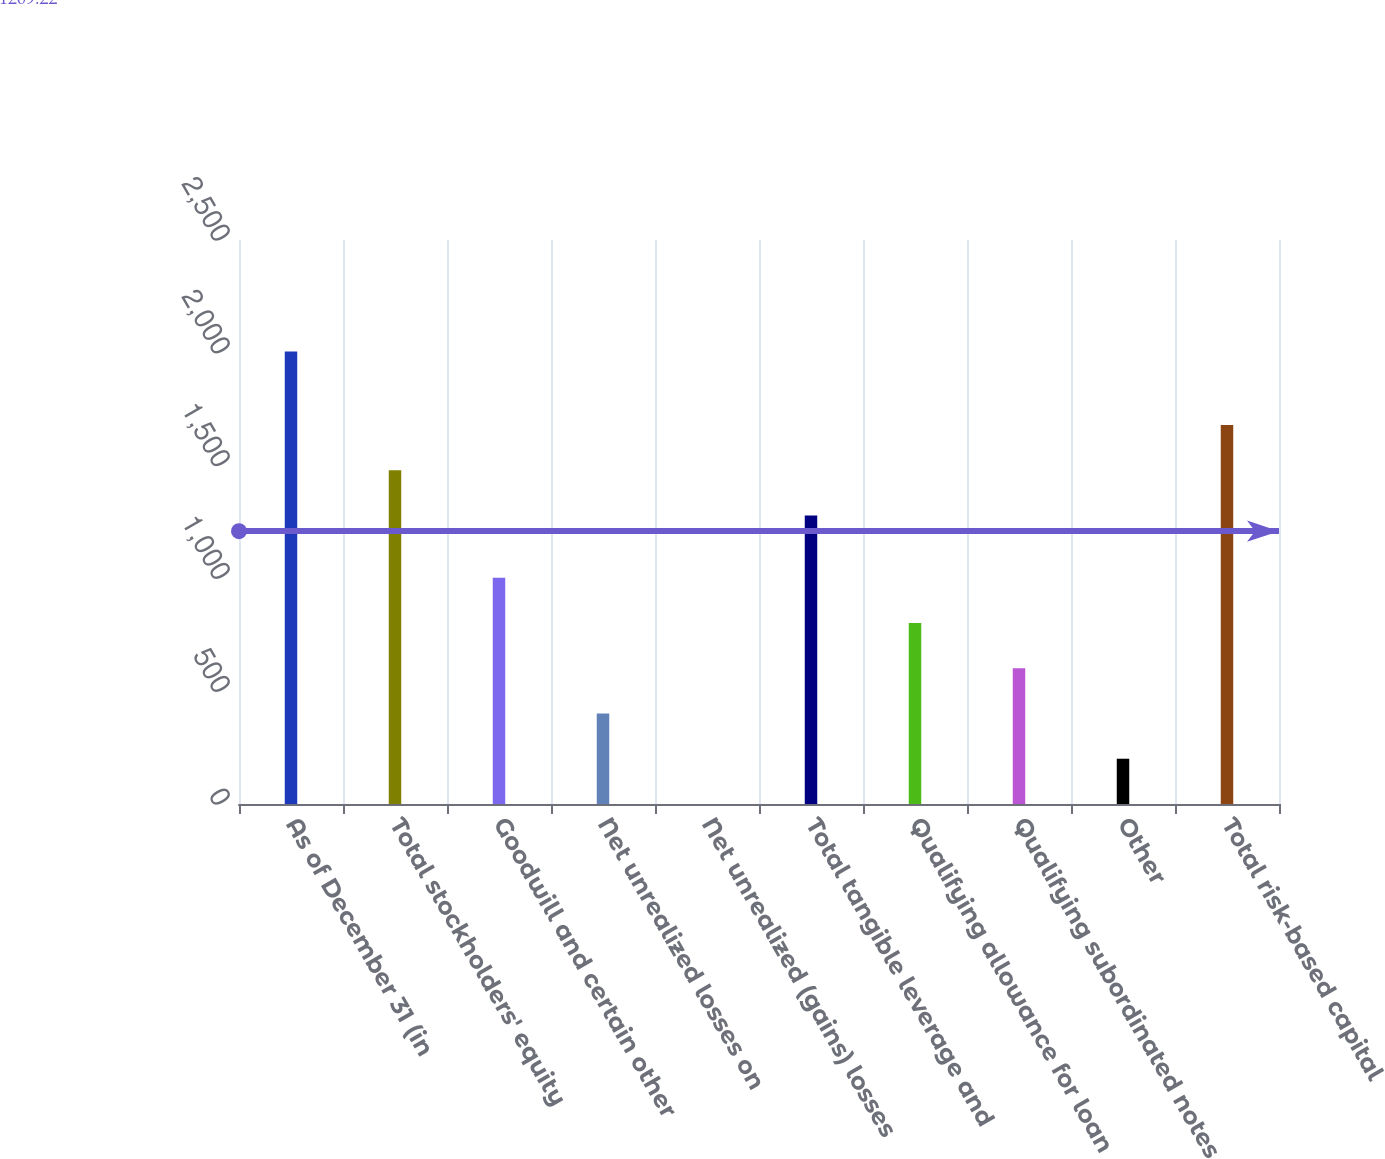<chart> <loc_0><loc_0><loc_500><loc_500><bar_chart><fcel>As of December 31 (in<fcel>Total stockholders' equity<fcel>Goodwill and certain other<fcel>Net unrealized losses on<fcel>Net unrealized (gains) losses<fcel>Total tangible leverage and<fcel>Qualifying allowance for loan<fcel>Qualifying subordinated notes<fcel>Other<fcel>Total risk-based capital<nl><fcel>2006<fcel>1478.99<fcel>1003.05<fcel>401.28<fcel>0.1<fcel>1278.4<fcel>802.46<fcel>601.87<fcel>200.69<fcel>1679.58<nl></chart> 